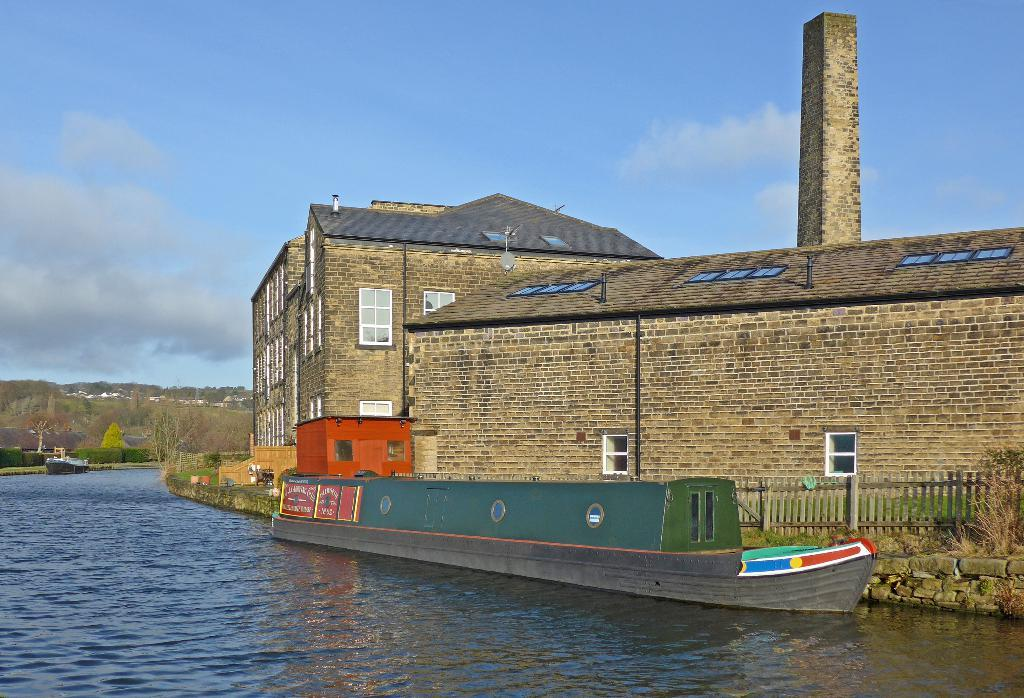What type of structures can be seen in the image? There are buildings in the image. What is separating the buildings from the water? There is a fence in the image. What is floating on the water in the image? There is a boat in the image. What is the primary feature of the water in the image? Water is visible in the image. What can be seen in the background of the image? There are trees in the background of the image. What is visible above the trees and buildings? The sky is visible in the image. What is present in the sky? Clouds are present in the sky. What type of news can be seen being delivered by the vessel in the image? There is no vessel present in the image, and therefore no news delivery can be observed. How many screws are visible on the boat in the image? There is no boat with screws present in the image; it features a boat without visible screws. 